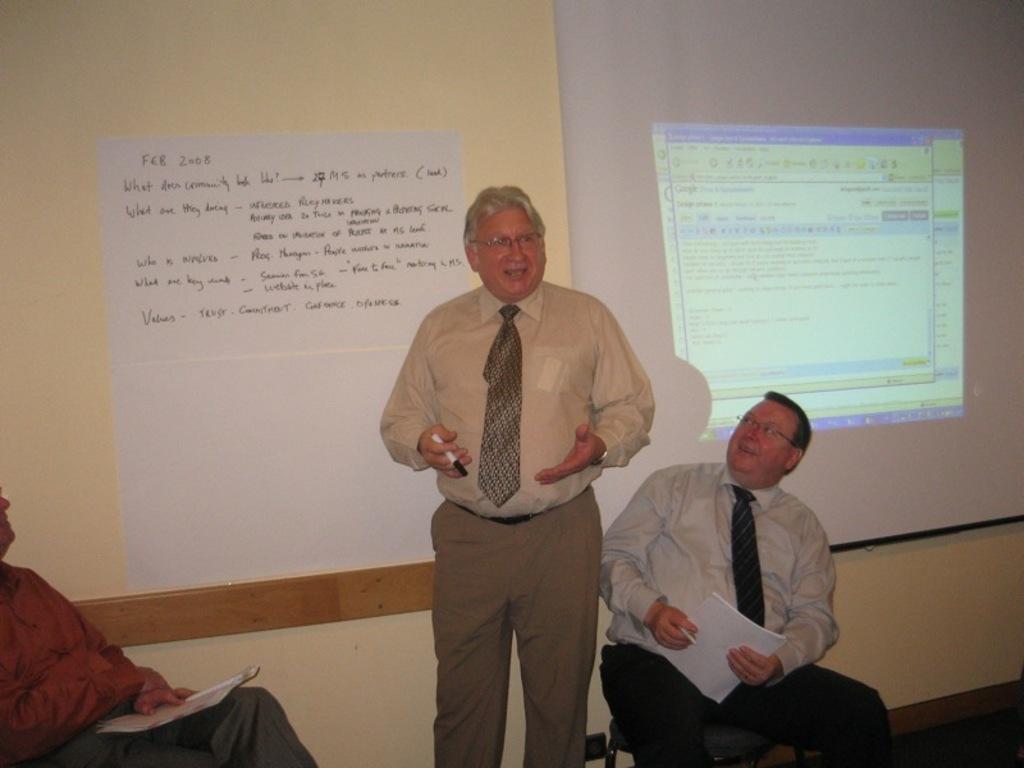Please provide a concise description of this image. This is the picture of a room. In this image there is a person standing and talking and he is holding the marker and there are two persons sitting and holding the papers. At the back there is a paper on the wall and there is a text on the paper and there is a screen. 